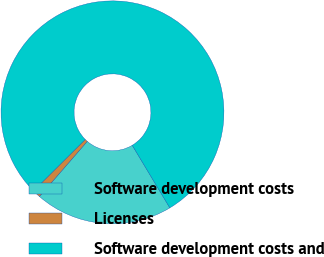Convert chart. <chart><loc_0><loc_0><loc_500><loc_500><pie_chart><fcel>Software development costs<fcel>Licenses<fcel>Software development costs and<nl><fcel>19.99%<fcel>1.17%<fcel>78.85%<nl></chart> 